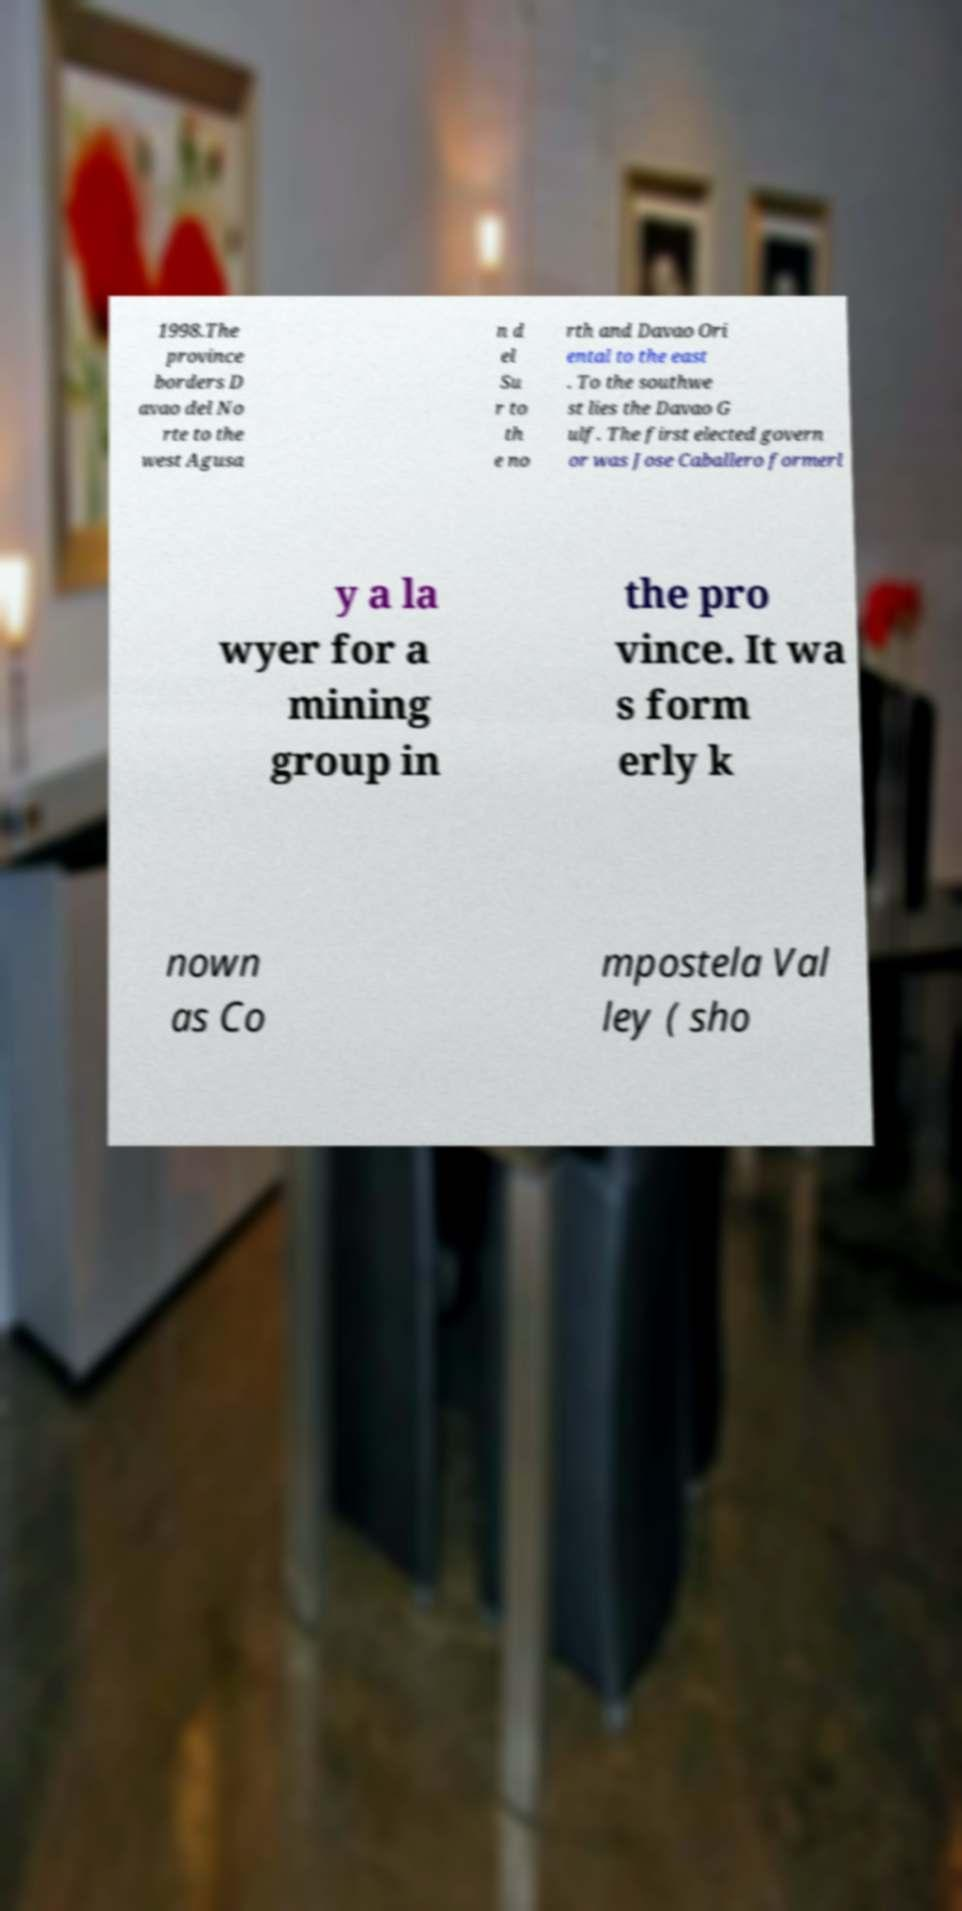What messages or text are displayed in this image? I need them in a readable, typed format. 1998.The province borders D avao del No rte to the west Agusa n d el Su r to th e no rth and Davao Ori ental to the east . To the southwe st lies the Davao G ulf. The first elected govern or was Jose Caballero formerl y a la wyer for a mining group in the pro vince. It wa s form erly k nown as Co mpostela Val ley ( sho 